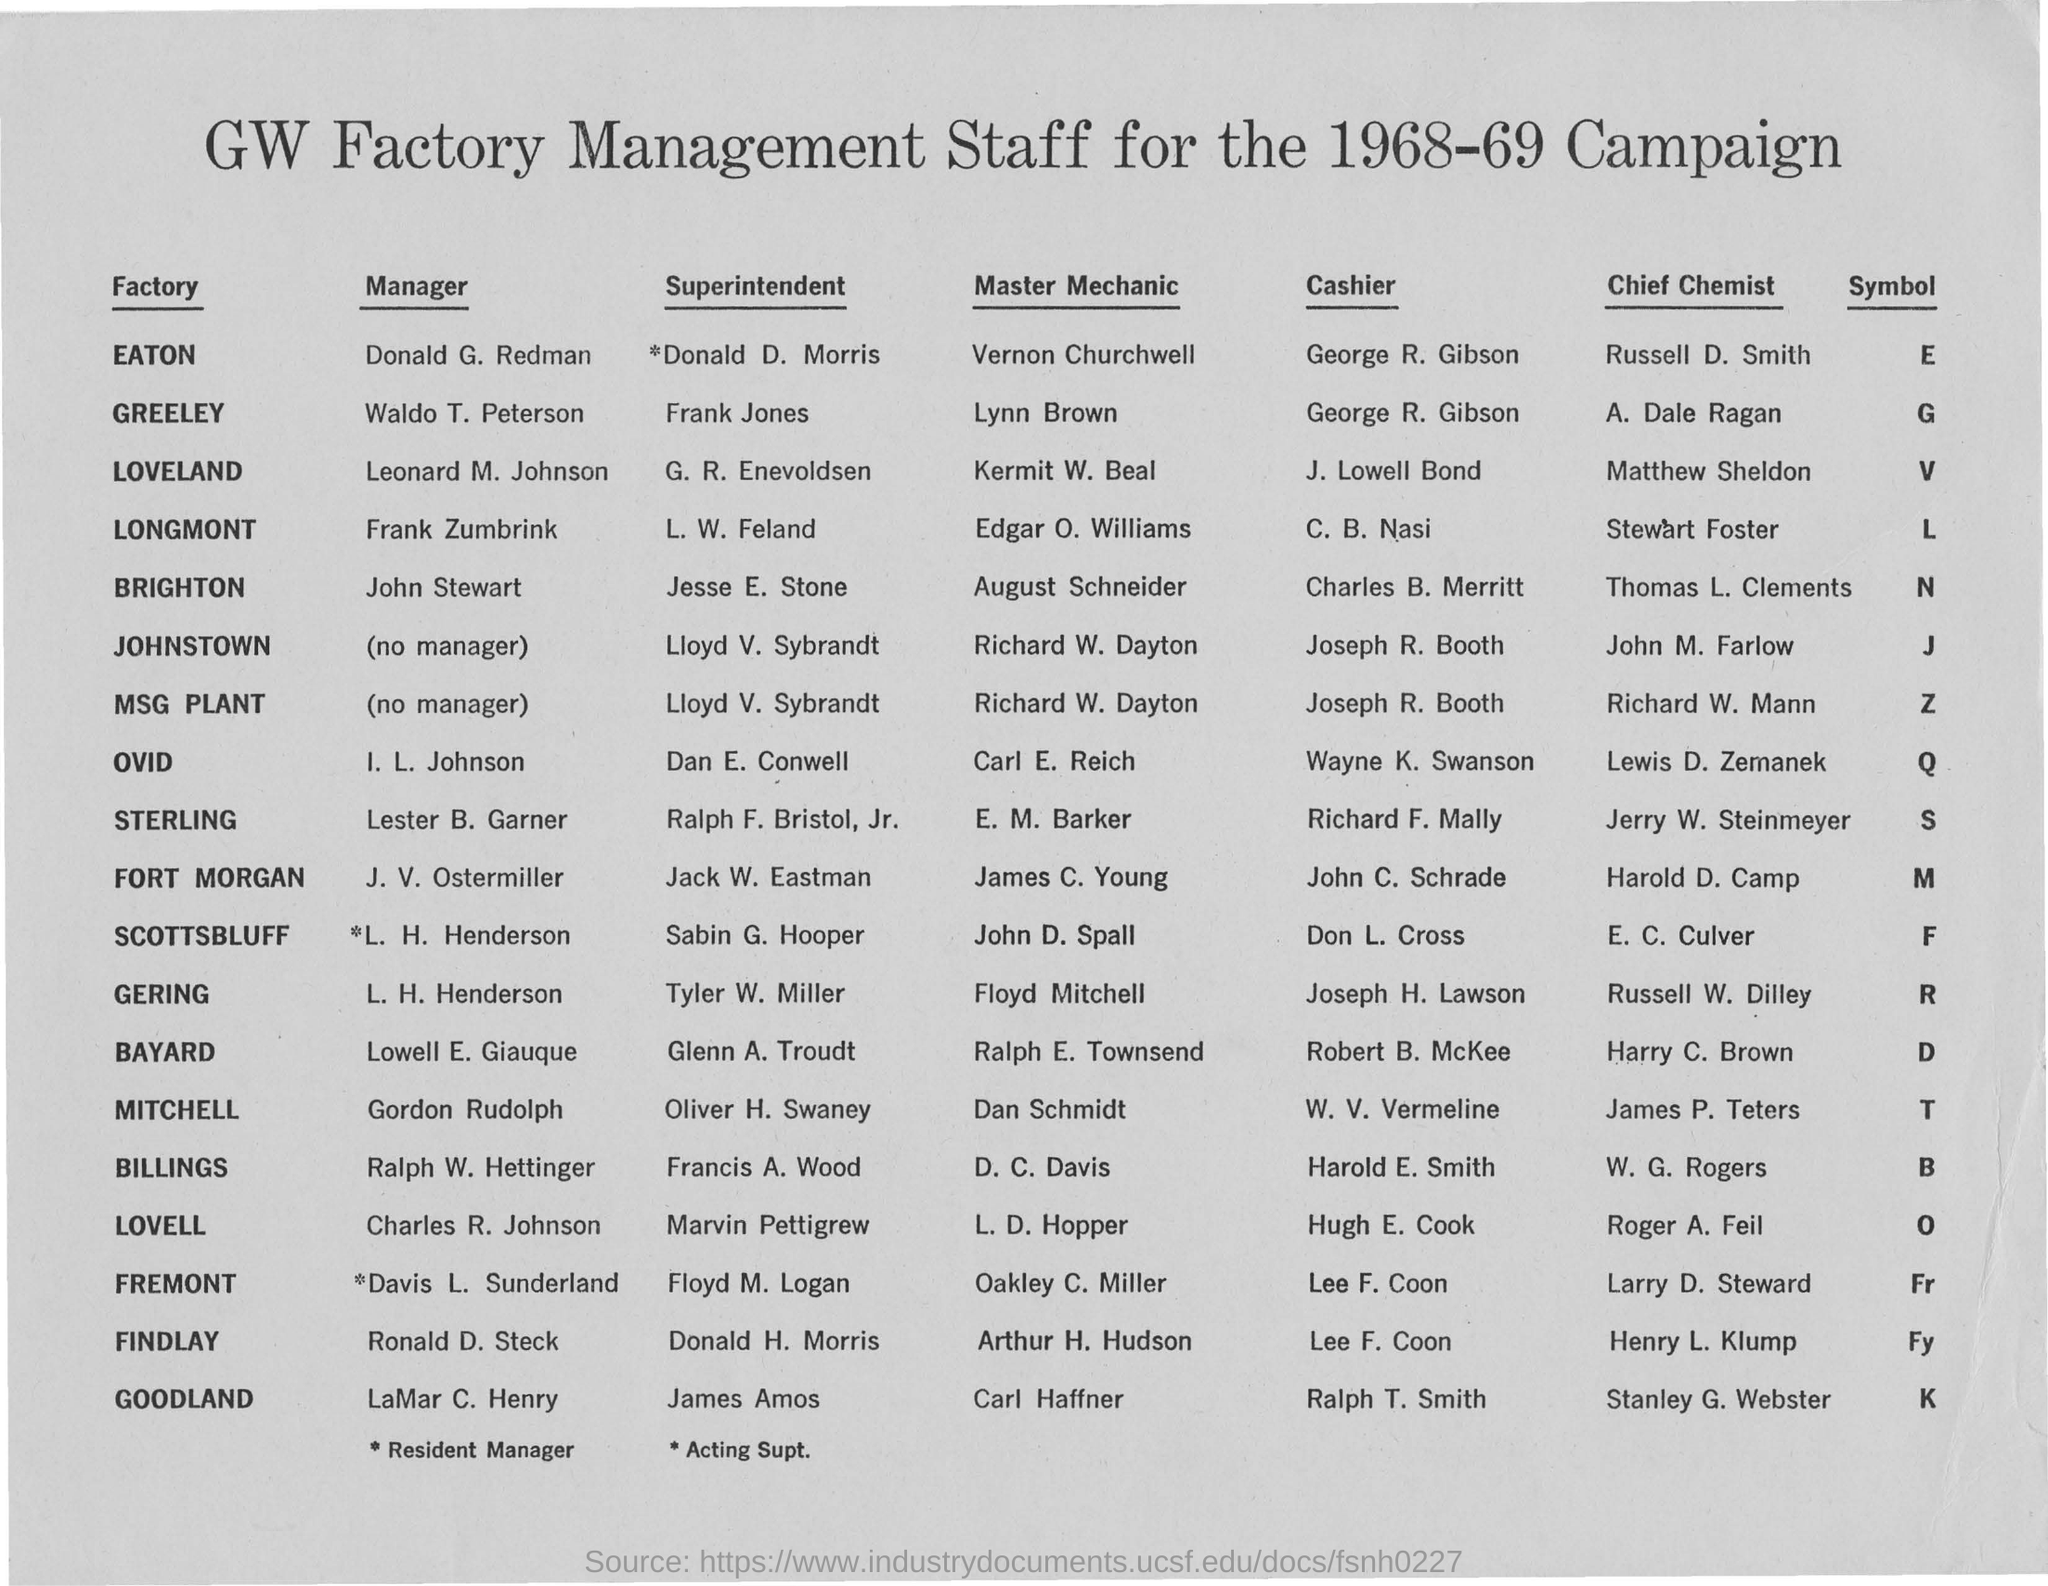Outline some significant characteristics in this image. The symbol of GOODLAND factory is K.. The heading of the document is "GW Factory Management Staff for the 1968-69 Campaign. Vernon Churchwell is the Master Mechanic of the EATON factory. Donald G. Redman is the manager of EATON factory. 